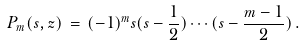Convert formula to latex. <formula><loc_0><loc_0><loc_500><loc_500>P _ { m } ( s , z ) \, = \, ( - 1 ) ^ { m } s ( s - \frac { 1 } { 2 } ) \cdots ( s - \frac { m - 1 } { 2 } ) \, .</formula> 